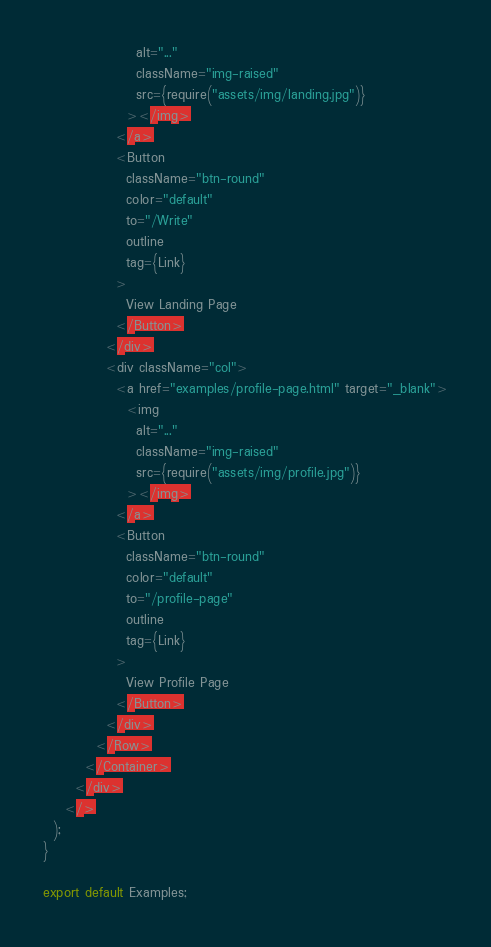Convert code to text. <code><loc_0><loc_0><loc_500><loc_500><_JavaScript_>                  alt="..."
                  className="img-raised"
                  src={require("assets/img/landing.jpg")}
                ></img>
              </a>
              <Button
                className="btn-round"
                color="default"
                to="/Write"
                outline
                tag={Link}
              >
                View Landing Page
              </Button>
            </div>
            <div className="col">
              <a href="examples/profile-page.html" target="_blank">
                <img
                  alt="..."
                  className="img-raised"
                  src={require("assets/img/profile.jpg")}
                ></img>
              </a>
              <Button
                className="btn-round"
                color="default"
                to="/profile-page"
                outline
                tag={Link}
              >
                View Profile Page
              </Button>
            </div>
          </Row>
        </Container>
      </div>
    </>
  );
}

export default Examples;
</code> 